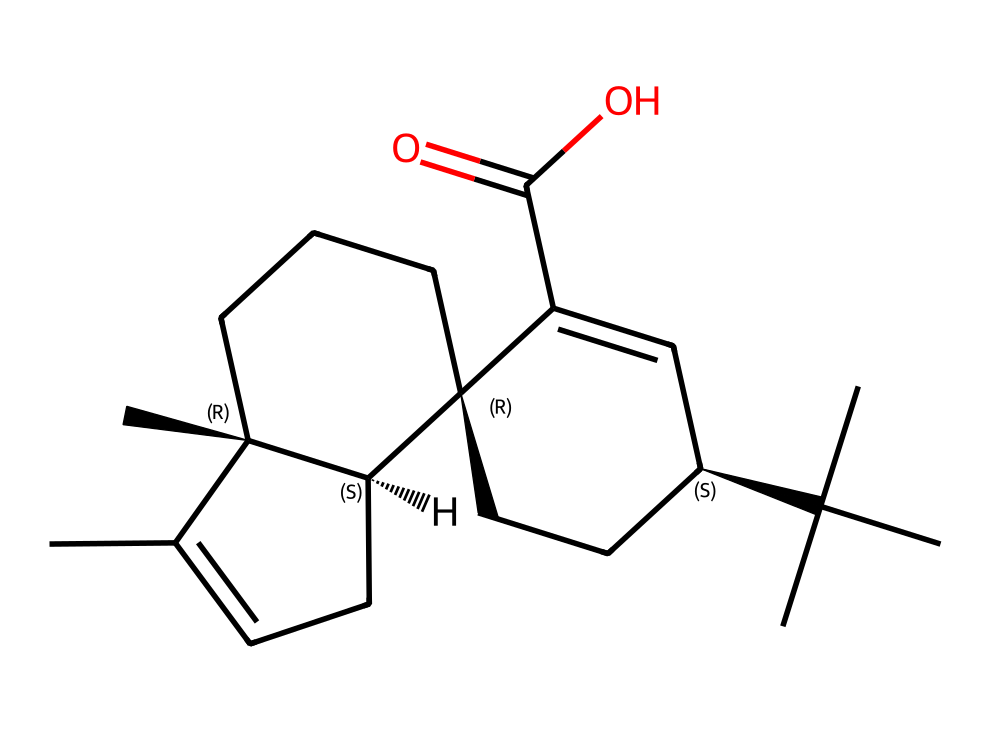What is the total number of carbon atoms in this compound? By examining the SMILES representation, we can count the carbon atoms. Each 'C' in the SMILES indicates a carbon atom. Careful counting reveals that there are 20 carbon atoms in the structure.
Answer: 20 What functional group is present in this chemical structure? The presence of 'C(=O)O' in the structure indicates a carboxylic acid group, as it shows a carbon double-bonded to an oxygen and single-bonded to a hydroxyl group (–OH).
Answer: carboxylic acid How many rings are formed in the chemical structure? Analyzing the connections and structural layout in the SMILES, we can identify three distinct cycles or rings, each formed by a series of interconnected carbon atoms.
Answer: 3 Is this compound an imide? To determine if this compound is an imide, we look for specific structural characteristics typical of imides, including the typical nitrogen atoms bonded to carbonyl groups. This compound lacks these features and is not classified as an imide.
Answer: no What is the degree of unsaturation in this compound? The degree of unsaturation can be calculated by evaluating the number of double bonds and rings compared to the maximum number of hydrogen atoms based on the carbon count. In this case, the structure presents multiple double bonds and rings, leading to a degree of unsaturation of 5.
Answer: 5 Which part of the molecule is likely responsible for its interaction with the bow hairs? The large hydrophobic carbon chain structure surrounding polar functional groups, specifically the carboxylic acid, suggests that this area will help in gripping and adhering to the bow hairs.
Answer: hydrophobic carbon chain What might be the overall polarity of this compound? Because the structure contains both hydrophobic carbon chains and a polar functional group (the carboxylic acid), the compound shows characteristics of amphipathic nature, contributing to its overall polarity.
Answer: amphipathic 